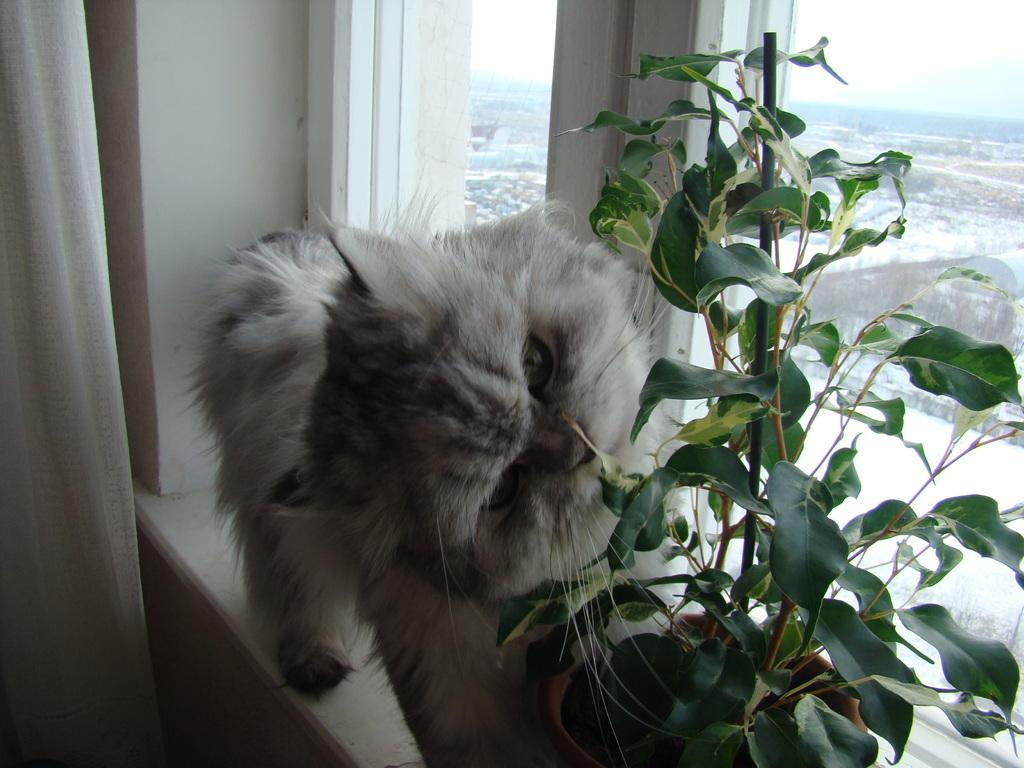What type of animal can be seen in the image? There is a cat in the image. What other object is present in the image? There is a house plant in the image. What architectural feature is visible in the image? There is a window in the image. What type of window treatment is present in the image? There is a curtain associated with the window. What can be seen through the window in the image? The sky is visible through the window. What month is it in the image? The month cannot be determined from the image, as there is no information provided about the time of year. What direction is the cat facing in the image? The direction the cat is facing cannot be determined from the image, as the cat's orientation is not specified. 